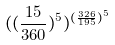<formula> <loc_0><loc_0><loc_500><loc_500>( ( \frac { 1 5 } { 3 6 0 } ) ^ { 5 } ) ^ { ( \frac { 3 2 6 } { 1 9 5 } ) ^ { 5 } }</formula> 